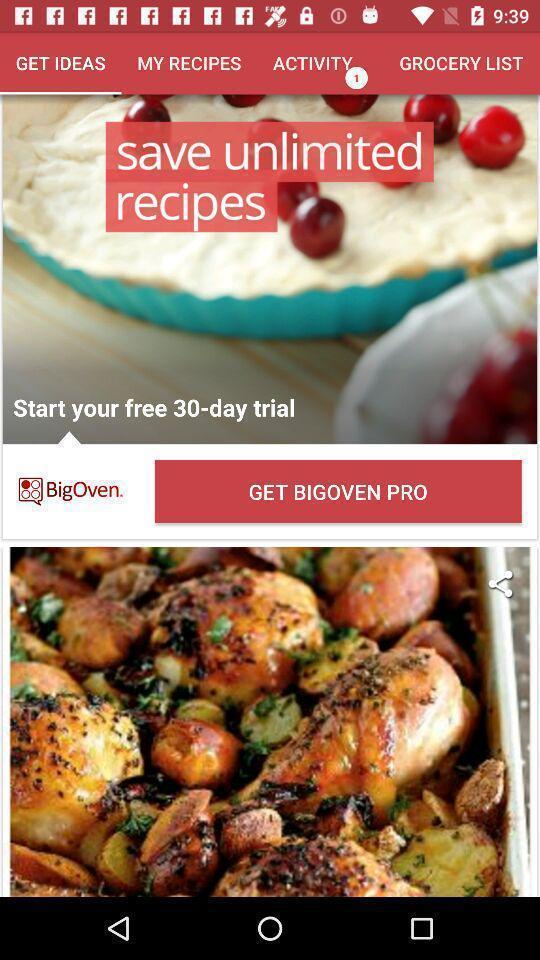Give me a narrative description of this picture. Screen shows about recipes on a cooking app. 